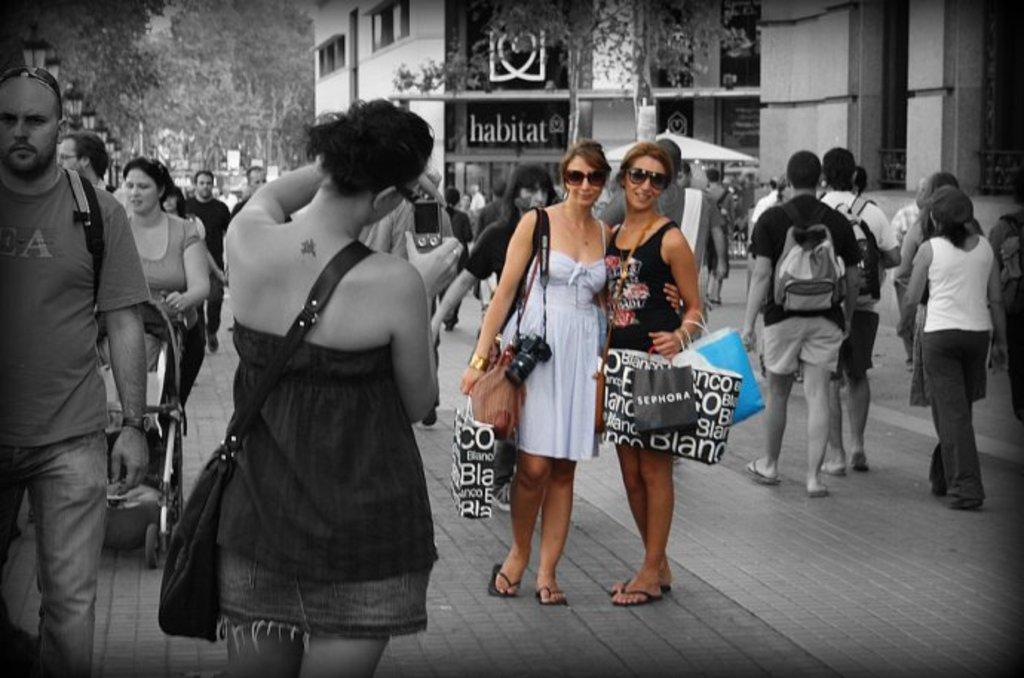How would you summarize this image in a sentence or two? It is a black and white image there are many people on the pavement and among them only two women are highlighted, in the background there is a building. 